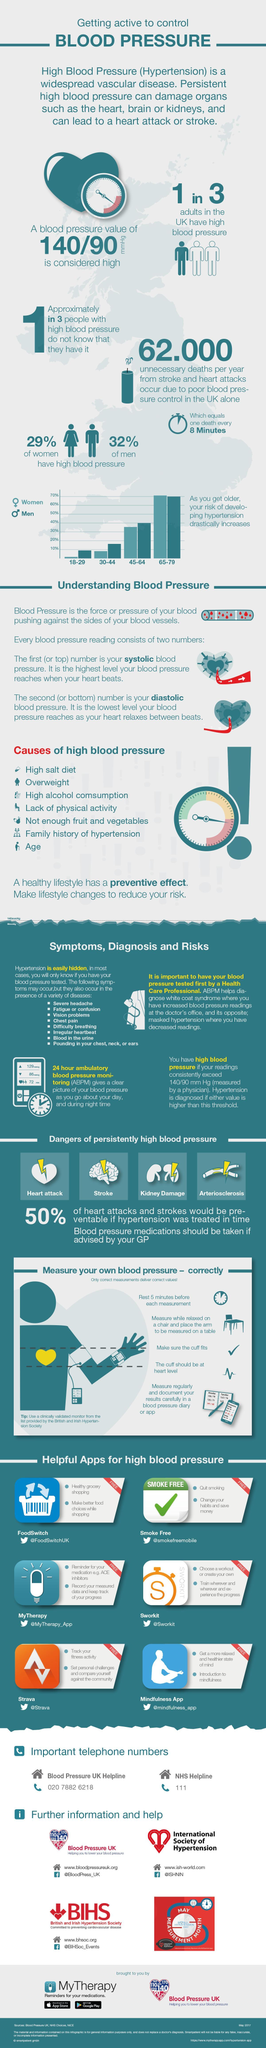In the age group 18 to 29 who have a higher risk of developing hypertension ?
Answer the question with a short phrase. Men What are the two tools for documenting the results of your blood pressure measurement ? Blood pressure diary, app Which of the following dangers are a result of persistently high blood pressure - cancer, heart attack, migraine, stroke, diabetes and kidney damage ? Heart attack, stroke, kidney damage What is the name of the app that will help in healthy grocery shopping ? FoodSwitch How many apps are available to help people with high blood pressure ? 6 Women in which age group have a higher risk of developing hypertension when compared to to men ? 65-79 What is the name of the app that helps remind patients to take their medication on time ? MyTherapy What is the name of the condition where a person shows an increased blood pressure reading when at the doctor's office only? White coat syndrome Blood in the urine and vision problems are the two symptoms of which condition ? Hypertension While measuring your blood pressure where should you place the arm ? Table What is the name of the app which has a tick mark for its icon ? Smoke Free 